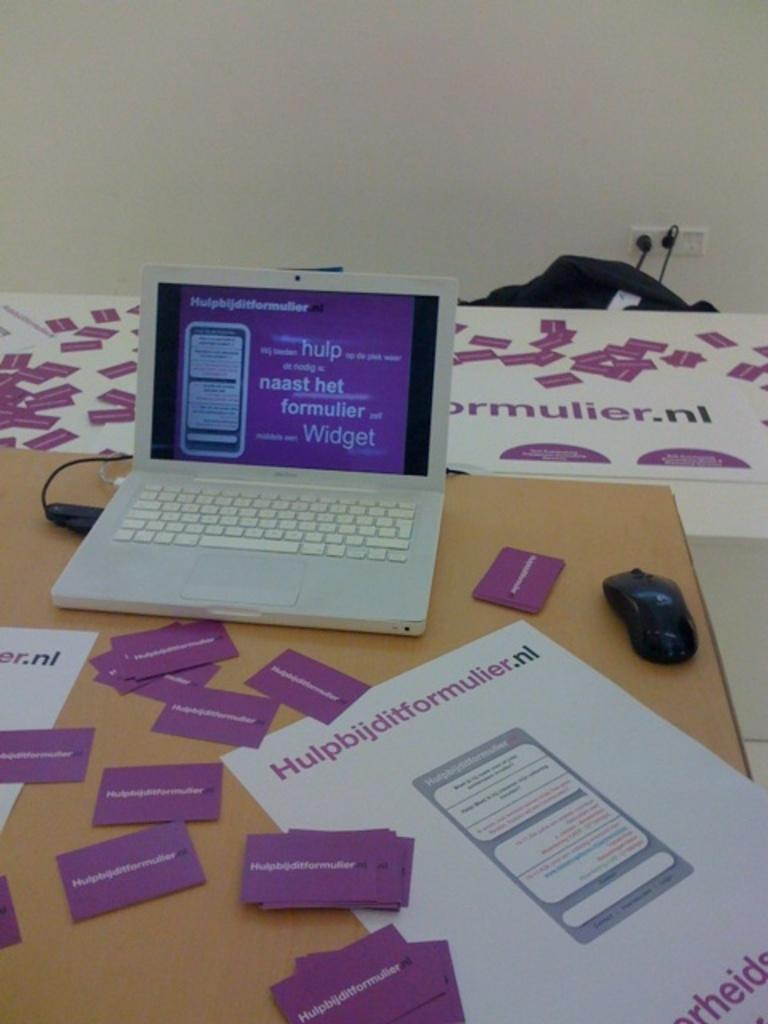<image>
Render a clear and concise summary of the photo. Small laptop on a table with business cards from "hulpbijditformulier". 